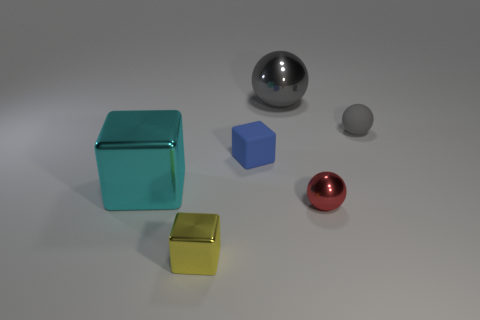There is a metal block that is the same size as the red shiny object; what color is it?
Offer a very short reply. Yellow. Are the small blue block and the gray sphere that is left of the red object made of the same material?
Your answer should be compact. No. How many other objects are the same size as the red metal sphere?
Keep it short and to the point. 3. There is a gray object that is right of the big metal thing that is on the right side of the cyan metal object; are there any tiny blue matte blocks that are to the right of it?
Make the answer very short. No. What is the size of the blue matte object?
Your answer should be compact. Small. There is a gray thing in front of the big gray thing; how big is it?
Ensure brevity in your answer.  Small. There is a rubber object that is on the right side of the blue cube; does it have the same size as the small red object?
Offer a terse response. Yes. Is there anything else that has the same color as the large cube?
Make the answer very short. No. The cyan thing is what shape?
Provide a succinct answer. Cube. What number of small objects are both behind the red metal thing and to the left of the red shiny ball?
Your answer should be compact. 1. 